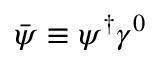Convert formula to latex. <formula><loc_0><loc_0><loc_500><loc_500>{ \bar { \psi } } \equiv \psi ^ { \dagger } \gamma ^ { 0 }</formula> 